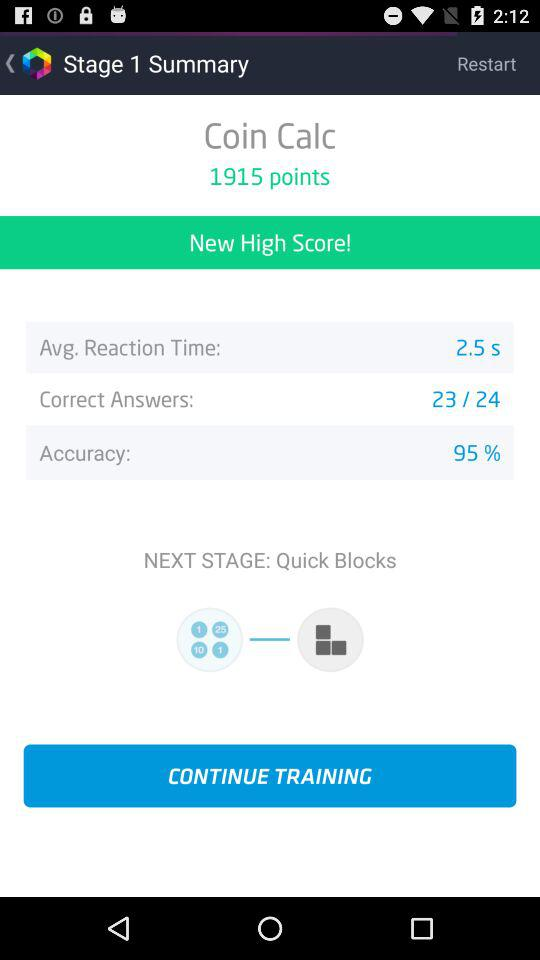How many more correct answers do I need to get a perfect score of 24/24?
Answer the question using a single word or phrase. 1 